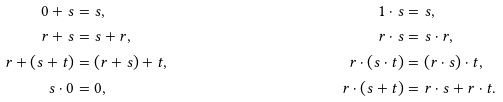<formula> <loc_0><loc_0><loc_500><loc_500>0 + s & = s , & 1 \cdot s & = s , \\ r + s & = s + r , & r \cdot s & = s \cdot r , \\ r + ( s + t ) & = ( r + s ) + t , & r \cdot ( s \cdot t ) & = ( r \cdot s ) \cdot t , \\ s \cdot 0 & = 0 , & r \cdot ( s + t ) & = r \cdot s + r \cdot t .</formula> 